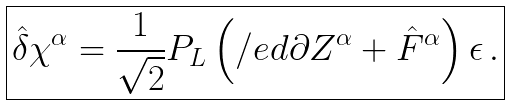Convert formula to latex. <formula><loc_0><loc_0><loc_500><loc_500>\boxed { \hat { \delta } \chi ^ { \alpha } = \frac { 1 } { \sqrt { 2 } } P _ { L } \left ( \slash e d { \partial } Z ^ { \alpha } + \hat { F } ^ { \alpha } \right ) \epsilon \, . }</formula> 